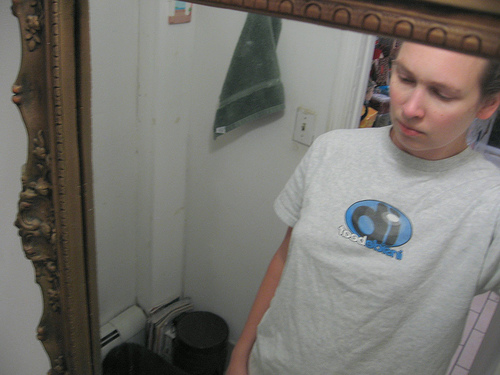<image>
Is there a towel in front of the wall? Yes. The towel is positioned in front of the wall, appearing closer to the camera viewpoint. 